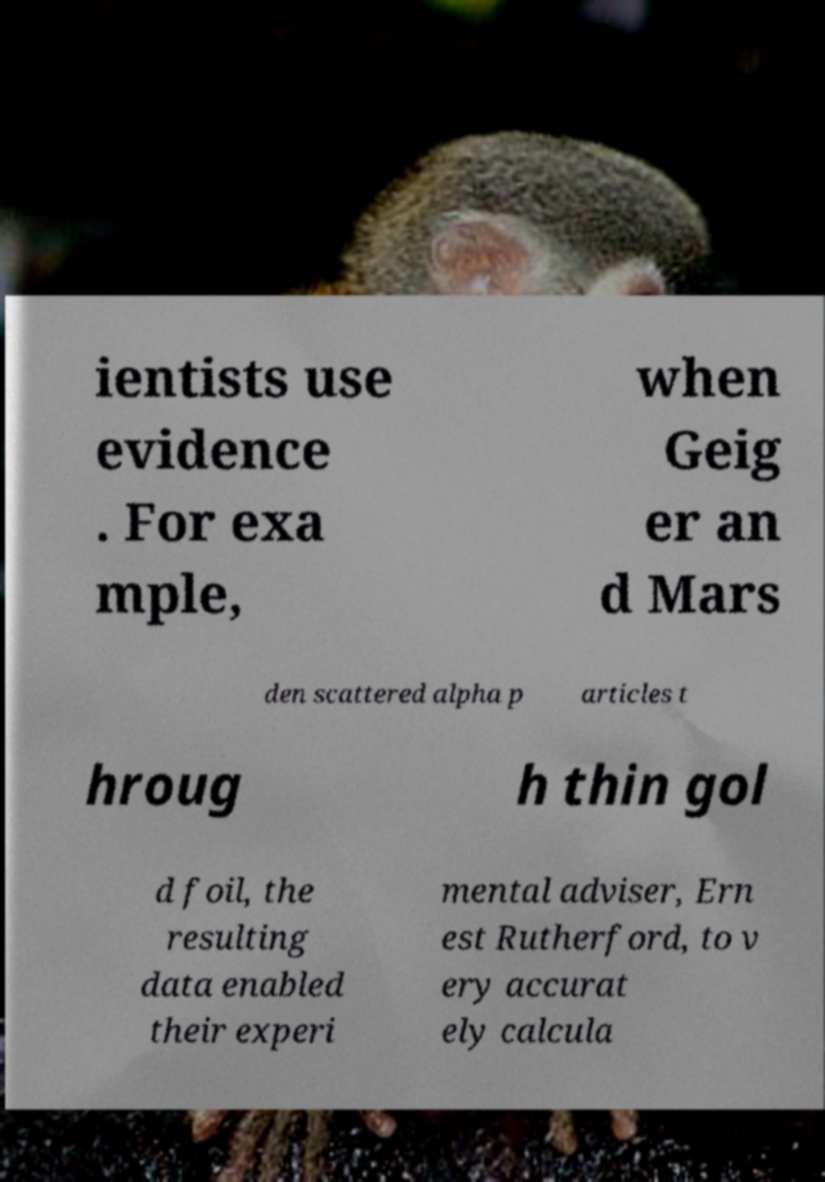Please read and relay the text visible in this image. What does it say? ientists use evidence . For exa mple, when Geig er an d Mars den scattered alpha p articles t hroug h thin gol d foil, the resulting data enabled their experi mental adviser, Ern est Rutherford, to v ery accurat ely calcula 